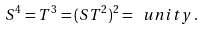Convert formula to latex. <formula><loc_0><loc_0><loc_500><loc_500>S ^ { 4 } = T ^ { 3 } = ( S T ^ { 2 } ) ^ { 2 } = \ u n i t y \, .</formula> 